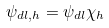Convert formula to latex. <formula><loc_0><loc_0><loc_500><loc_500>\psi _ { d l , h } = \psi _ { d l } \chi _ { h }</formula> 